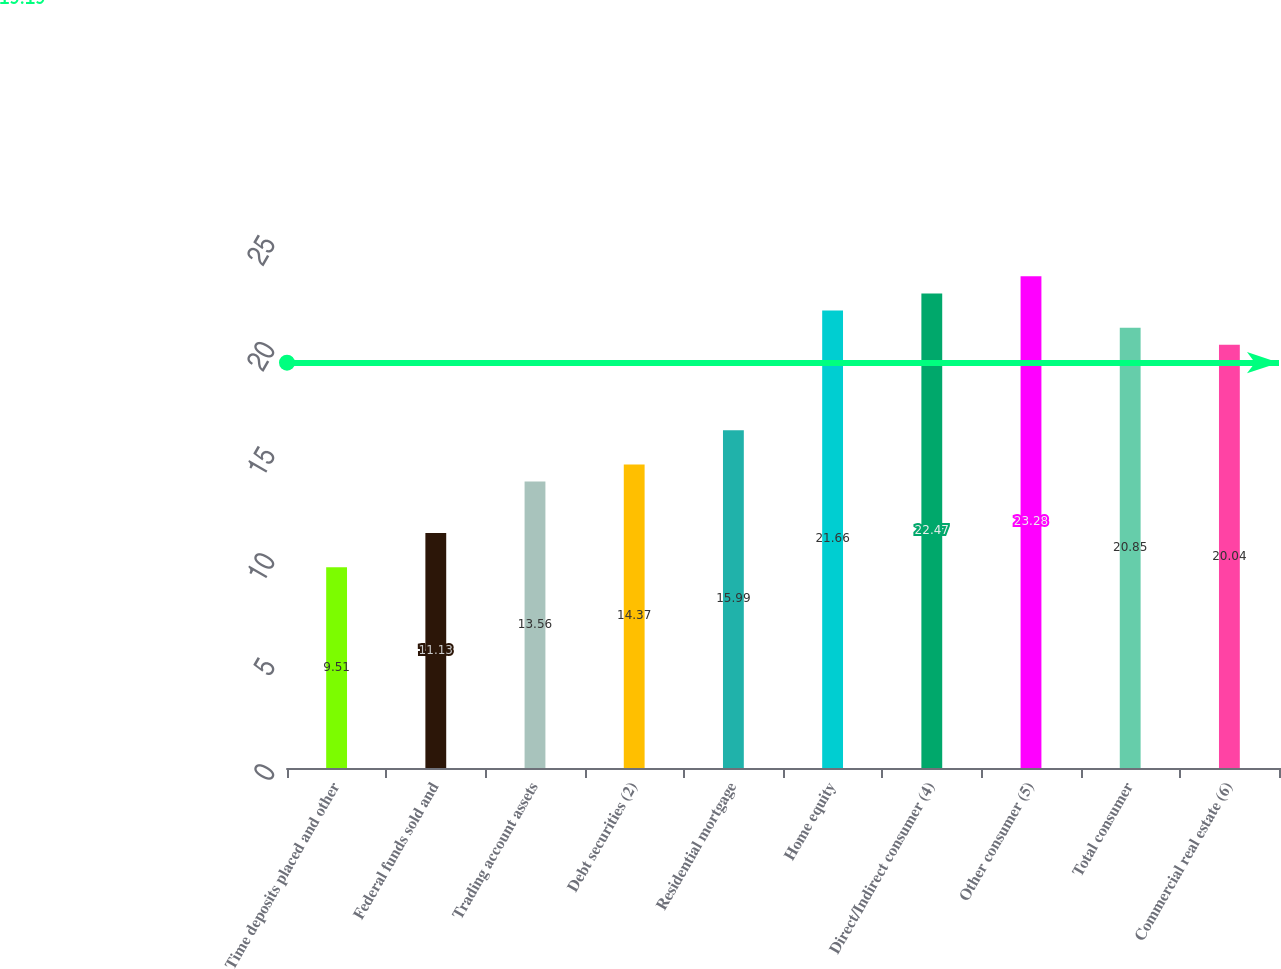Convert chart to OTSL. <chart><loc_0><loc_0><loc_500><loc_500><bar_chart><fcel>Time deposits placed and other<fcel>Federal funds sold and<fcel>Trading account assets<fcel>Debt securities (2)<fcel>Residential mortgage<fcel>Home equity<fcel>Direct/Indirect consumer (4)<fcel>Other consumer (5)<fcel>Total consumer<fcel>Commercial real estate (6)<nl><fcel>9.51<fcel>11.13<fcel>13.56<fcel>14.37<fcel>15.99<fcel>21.66<fcel>22.47<fcel>23.28<fcel>20.85<fcel>20.04<nl></chart> 